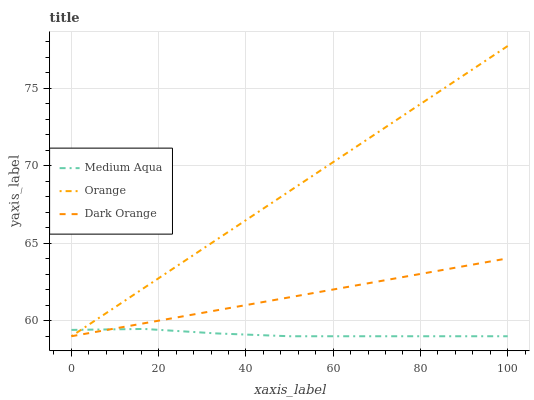Does Medium Aqua have the minimum area under the curve?
Answer yes or no. Yes. Does Orange have the maximum area under the curve?
Answer yes or no. Yes. Does Dark Orange have the minimum area under the curve?
Answer yes or no. No. Does Dark Orange have the maximum area under the curve?
Answer yes or no. No. Is Dark Orange the smoothest?
Answer yes or no. Yes. Is Medium Aqua the roughest?
Answer yes or no. Yes. Is Medium Aqua the smoothest?
Answer yes or no. No. Is Dark Orange the roughest?
Answer yes or no. No. Does Orange have the lowest value?
Answer yes or no. Yes. Does Orange have the highest value?
Answer yes or no. Yes. Does Dark Orange have the highest value?
Answer yes or no. No. Does Dark Orange intersect Orange?
Answer yes or no. Yes. Is Dark Orange less than Orange?
Answer yes or no. No. Is Dark Orange greater than Orange?
Answer yes or no. No. 